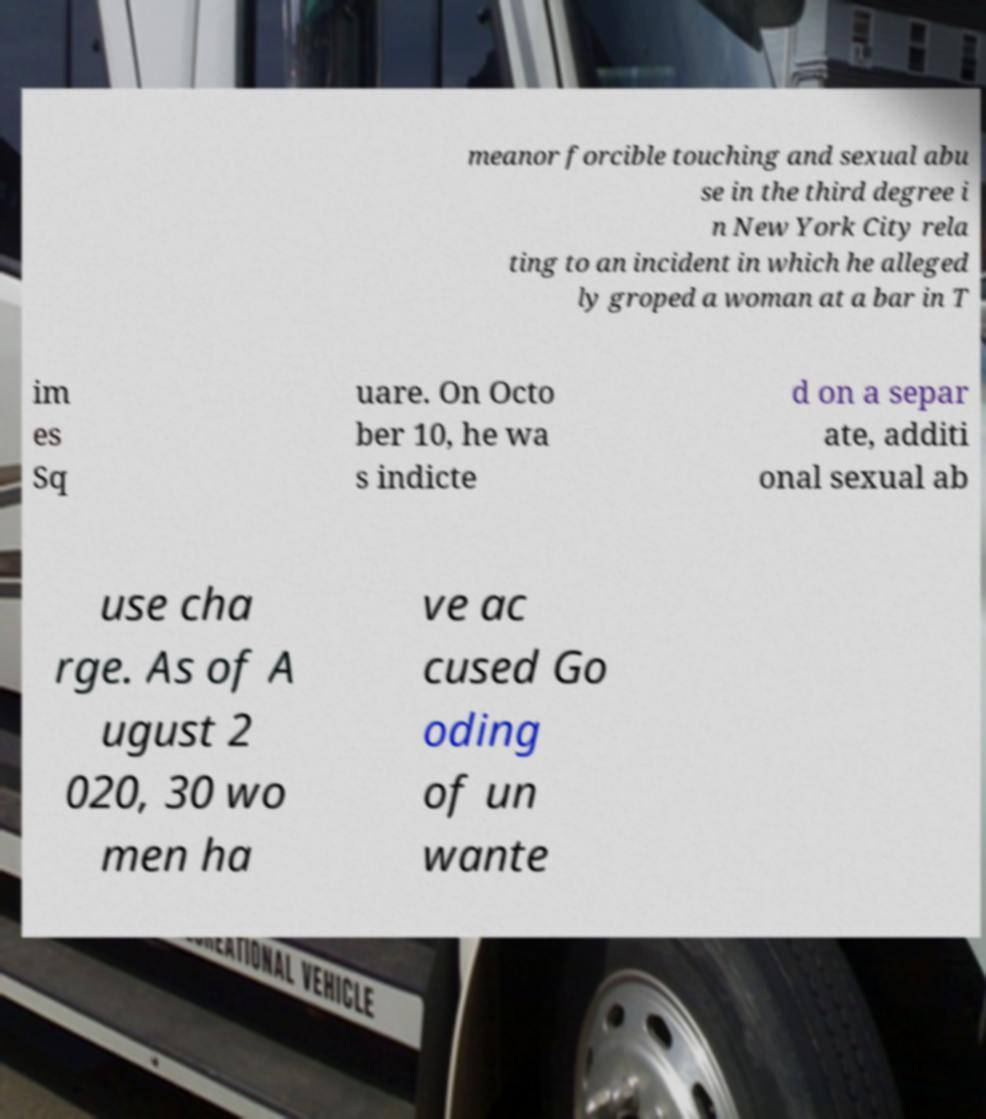Could you assist in decoding the text presented in this image and type it out clearly? meanor forcible touching and sexual abu se in the third degree i n New York City rela ting to an incident in which he alleged ly groped a woman at a bar in T im es Sq uare. On Octo ber 10, he wa s indicte d on a separ ate, additi onal sexual ab use cha rge. As of A ugust 2 020, 30 wo men ha ve ac cused Go oding of un wante 